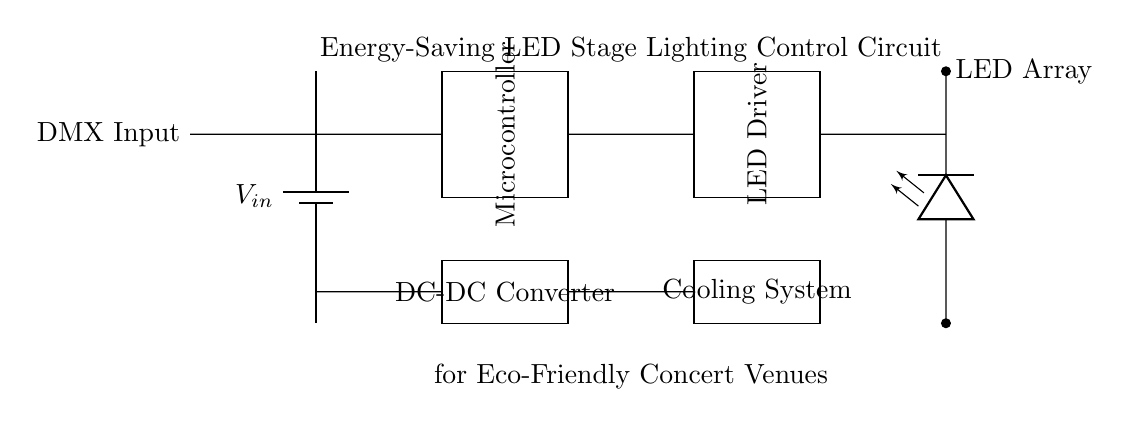What type of power supply is used in this circuit? The circuit features a battery, which is indicated by the component labeled as "battery1". It serves as the source of electrical energy for the entire system.
Answer: battery What is the purpose of the microcontroller in this circuit? The microcontroller is responsible for controlling the LED Driver based on the input received from the DMX Input. It processes commands and manages the light output.
Answer: control How many main components are shown in the circuit diagram? Counting the battery, microcontroller, LED Driver, LED Array, DC-DC Converter, and Cooling System yields a total of six main components in the circuit.
Answer: six What connection type is used for the DMX input? The DMX Input is represented as a short connection leading into the circuit, signifying a direct connection to the microcontroller's receiving point.
Answer: short Explain the function of the DC-DC converter in this circuit. The DC-DC Converter steps down or steps up the input voltage to provide the appropriate level of voltage required by the LED Driver and ensures energy efficiency in the lighting system. It regulates power from the battery to match the requirements of other components.
Answer: voltage regulation What component is responsible for maintaining the temperature in this circuit? The Cooling System is specifically designed to manage the temperature, preventing overheating of the components, especially during high power operation of LED lights.
Answer: Cooling System What is the LED Array used for in this circuit? The LED Array represents the actual lighting elements that produce light for the stage. It is the component that directly interacts with the audience to deliver visual effects during performances.
Answer: lighting 